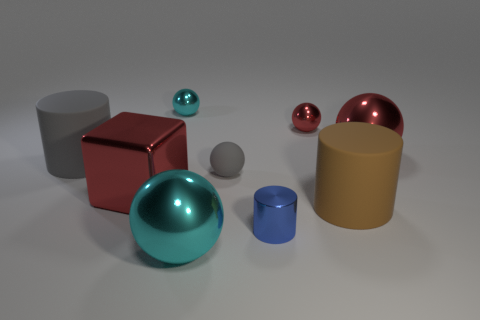How many things are either small gray spheres or big cyan metal balls?
Offer a terse response. 2. Does the large cylinder behind the small matte thing have the same material as the blue cylinder?
Keep it short and to the point. No. What number of things are either big rubber objects that are left of the big brown cylinder or tiny gray spheres?
Offer a very short reply. 2. The large cube that is made of the same material as the blue object is what color?
Offer a terse response. Red. Is there another blue metallic block that has the same size as the shiny cube?
Keep it short and to the point. No. Do the big shiny ball behind the blue thing and the metallic cylinder have the same color?
Your answer should be compact. No. There is a big thing that is both behind the gray ball and right of the big gray cylinder; what is its color?
Offer a very short reply. Red. There is a cyan object that is the same size as the gray matte ball; what shape is it?
Provide a short and direct response. Sphere. Is there a brown thing of the same shape as the small blue thing?
Provide a short and direct response. Yes. There is a sphere that is right of the brown matte thing; is its size the same as the gray cylinder?
Offer a very short reply. Yes. 